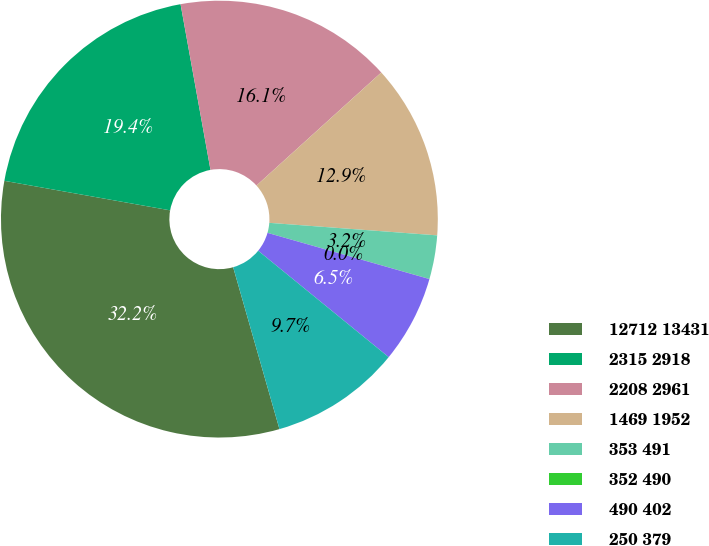Convert chart to OTSL. <chart><loc_0><loc_0><loc_500><loc_500><pie_chart><fcel>12712 13431<fcel>2315 2918<fcel>2208 2961<fcel>1469 1952<fcel>353 491<fcel>352 490<fcel>490 402<fcel>250 379<nl><fcel>32.24%<fcel>19.35%<fcel>16.13%<fcel>12.9%<fcel>3.23%<fcel>0.01%<fcel>6.46%<fcel>9.68%<nl></chart> 